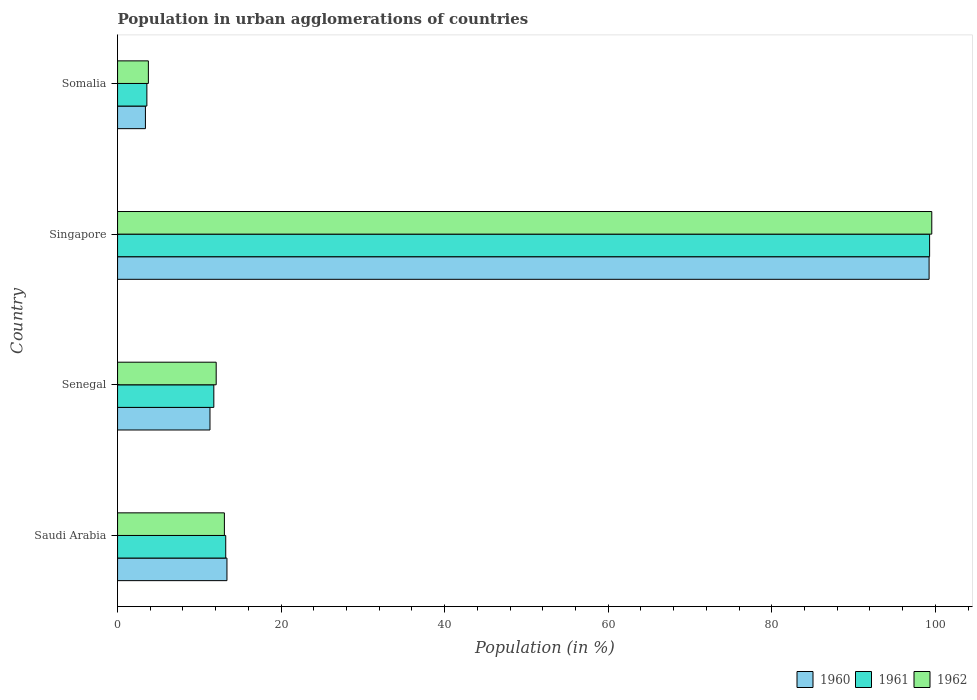How many different coloured bars are there?
Your response must be concise. 3. Are the number of bars per tick equal to the number of legend labels?
Offer a terse response. Yes. Are the number of bars on each tick of the Y-axis equal?
Your response must be concise. Yes. How many bars are there on the 3rd tick from the bottom?
Give a very brief answer. 3. What is the label of the 2nd group of bars from the top?
Your response must be concise. Singapore. What is the percentage of population in urban agglomerations in 1962 in Somalia?
Give a very brief answer. 3.77. Across all countries, what is the maximum percentage of population in urban agglomerations in 1960?
Offer a terse response. 99.23. Across all countries, what is the minimum percentage of population in urban agglomerations in 1962?
Provide a succinct answer. 3.77. In which country was the percentage of population in urban agglomerations in 1960 maximum?
Provide a succinct answer. Singapore. In which country was the percentage of population in urban agglomerations in 1961 minimum?
Provide a succinct answer. Somalia. What is the total percentage of population in urban agglomerations in 1961 in the graph?
Offer a terse response. 127.88. What is the difference between the percentage of population in urban agglomerations in 1960 in Senegal and that in Singapore?
Give a very brief answer. -87.93. What is the difference between the percentage of population in urban agglomerations in 1960 in Saudi Arabia and the percentage of population in urban agglomerations in 1961 in Somalia?
Provide a succinct answer. 9.79. What is the average percentage of population in urban agglomerations in 1962 per country?
Give a very brief answer. 32.11. What is the difference between the percentage of population in urban agglomerations in 1962 and percentage of population in urban agglomerations in 1961 in Singapore?
Give a very brief answer. 0.27. What is the ratio of the percentage of population in urban agglomerations in 1962 in Singapore to that in Somalia?
Give a very brief answer. 26.41. What is the difference between the highest and the second highest percentage of population in urban agglomerations in 1962?
Keep it short and to the point. 86.5. What is the difference between the highest and the lowest percentage of population in urban agglomerations in 1961?
Give a very brief answer. 95.71. In how many countries, is the percentage of population in urban agglomerations in 1960 greater than the average percentage of population in urban agglomerations in 1960 taken over all countries?
Your response must be concise. 1. Is the sum of the percentage of population in urban agglomerations in 1960 in Saudi Arabia and Singapore greater than the maximum percentage of population in urban agglomerations in 1961 across all countries?
Ensure brevity in your answer.  Yes. What does the 2nd bar from the top in Somalia represents?
Make the answer very short. 1961. Is it the case that in every country, the sum of the percentage of population in urban agglomerations in 1961 and percentage of population in urban agglomerations in 1962 is greater than the percentage of population in urban agglomerations in 1960?
Keep it short and to the point. Yes. Are all the bars in the graph horizontal?
Keep it short and to the point. Yes. How many countries are there in the graph?
Ensure brevity in your answer.  4. What is the difference between two consecutive major ticks on the X-axis?
Your response must be concise. 20. Are the values on the major ticks of X-axis written in scientific E-notation?
Keep it short and to the point. No. Does the graph contain grids?
Offer a terse response. No. How many legend labels are there?
Offer a terse response. 3. How are the legend labels stacked?
Give a very brief answer. Horizontal. What is the title of the graph?
Provide a short and direct response. Population in urban agglomerations of countries. What is the label or title of the X-axis?
Provide a short and direct response. Population (in %). What is the label or title of the Y-axis?
Offer a terse response. Country. What is the Population (in %) of 1960 in Saudi Arabia?
Provide a short and direct response. 13.38. What is the Population (in %) in 1961 in Saudi Arabia?
Ensure brevity in your answer.  13.23. What is the Population (in %) of 1962 in Saudi Arabia?
Make the answer very short. 13.06. What is the Population (in %) of 1960 in Senegal?
Give a very brief answer. 11.3. What is the Population (in %) in 1961 in Senegal?
Give a very brief answer. 11.77. What is the Population (in %) of 1962 in Senegal?
Offer a very short reply. 12.06. What is the Population (in %) of 1960 in Singapore?
Your response must be concise. 99.23. What is the Population (in %) in 1961 in Singapore?
Make the answer very short. 99.29. What is the Population (in %) of 1962 in Singapore?
Provide a short and direct response. 99.56. What is the Population (in %) in 1960 in Somalia?
Ensure brevity in your answer.  3.41. What is the Population (in %) in 1961 in Somalia?
Your response must be concise. 3.58. What is the Population (in %) in 1962 in Somalia?
Your response must be concise. 3.77. Across all countries, what is the maximum Population (in %) in 1960?
Make the answer very short. 99.23. Across all countries, what is the maximum Population (in %) of 1961?
Your answer should be compact. 99.29. Across all countries, what is the maximum Population (in %) of 1962?
Offer a very short reply. 99.56. Across all countries, what is the minimum Population (in %) of 1960?
Ensure brevity in your answer.  3.41. Across all countries, what is the minimum Population (in %) in 1961?
Make the answer very short. 3.58. Across all countries, what is the minimum Population (in %) in 1962?
Your response must be concise. 3.77. What is the total Population (in %) in 1960 in the graph?
Your answer should be compact. 127.31. What is the total Population (in %) in 1961 in the graph?
Keep it short and to the point. 127.88. What is the total Population (in %) of 1962 in the graph?
Provide a succinct answer. 128.45. What is the difference between the Population (in %) of 1960 in Saudi Arabia and that in Senegal?
Make the answer very short. 2.07. What is the difference between the Population (in %) in 1961 in Saudi Arabia and that in Senegal?
Offer a very short reply. 1.46. What is the difference between the Population (in %) of 1960 in Saudi Arabia and that in Singapore?
Make the answer very short. -85.85. What is the difference between the Population (in %) in 1961 in Saudi Arabia and that in Singapore?
Your response must be concise. -86.06. What is the difference between the Population (in %) in 1962 in Saudi Arabia and that in Singapore?
Provide a succinct answer. -86.5. What is the difference between the Population (in %) in 1960 in Saudi Arabia and that in Somalia?
Provide a short and direct response. 9.97. What is the difference between the Population (in %) of 1961 in Saudi Arabia and that in Somalia?
Provide a short and direct response. 9.64. What is the difference between the Population (in %) of 1962 in Saudi Arabia and that in Somalia?
Provide a succinct answer. 9.29. What is the difference between the Population (in %) of 1960 in Senegal and that in Singapore?
Offer a terse response. -87.93. What is the difference between the Population (in %) of 1961 in Senegal and that in Singapore?
Your response must be concise. -87.52. What is the difference between the Population (in %) of 1962 in Senegal and that in Singapore?
Your answer should be compact. -87.5. What is the difference between the Population (in %) in 1960 in Senegal and that in Somalia?
Provide a succinct answer. 7.89. What is the difference between the Population (in %) of 1961 in Senegal and that in Somalia?
Offer a terse response. 8.19. What is the difference between the Population (in %) of 1962 in Senegal and that in Somalia?
Provide a short and direct response. 8.29. What is the difference between the Population (in %) of 1960 in Singapore and that in Somalia?
Provide a short and direct response. 95.82. What is the difference between the Population (in %) of 1961 in Singapore and that in Somalia?
Provide a succinct answer. 95.71. What is the difference between the Population (in %) in 1962 in Singapore and that in Somalia?
Your answer should be very brief. 95.79. What is the difference between the Population (in %) of 1960 in Saudi Arabia and the Population (in %) of 1961 in Senegal?
Make the answer very short. 1.6. What is the difference between the Population (in %) in 1960 in Saudi Arabia and the Population (in %) in 1962 in Senegal?
Keep it short and to the point. 1.32. What is the difference between the Population (in %) in 1961 in Saudi Arabia and the Population (in %) in 1962 in Senegal?
Provide a short and direct response. 1.17. What is the difference between the Population (in %) in 1960 in Saudi Arabia and the Population (in %) in 1961 in Singapore?
Provide a succinct answer. -85.92. What is the difference between the Population (in %) of 1960 in Saudi Arabia and the Population (in %) of 1962 in Singapore?
Provide a succinct answer. -86.18. What is the difference between the Population (in %) in 1961 in Saudi Arabia and the Population (in %) in 1962 in Singapore?
Provide a short and direct response. -86.33. What is the difference between the Population (in %) in 1960 in Saudi Arabia and the Population (in %) in 1961 in Somalia?
Your answer should be compact. 9.79. What is the difference between the Population (in %) of 1960 in Saudi Arabia and the Population (in %) of 1962 in Somalia?
Give a very brief answer. 9.61. What is the difference between the Population (in %) in 1961 in Saudi Arabia and the Population (in %) in 1962 in Somalia?
Your response must be concise. 9.46. What is the difference between the Population (in %) in 1960 in Senegal and the Population (in %) in 1961 in Singapore?
Your answer should be very brief. -87.99. What is the difference between the Population (in %) in 1960 in Senegal and the Population (in %) in 1962 in Singapore?
Provide a succinct answer. -88.26. What is the difference between the Population (in %) in 1961 in Senegal and the Population (in %) in 1962 in Singapore?
Provide a succinct answer. -87.79. What is the difference between the Population (in %) of 1960 in Senegal and the Population (in %) of 1961 in Somalia?
Provide a succinct answer. 7.72. What is the difference between the Population (in %) in 1960 in Senegal and the Population (in %) in 1962 in Somalia?
Provide a succinct answer. 7.53. What is the difference between the Population (in %) in 1961 in Senegal and the Population (in %) in 1962 in Somalia?
Give a very brief answer. 8. What is the difference between the Population (in %) in 1960 in Singapore and the Population (in %) in 1961 in Somalia?
Keep it short and to the point. 95.65. What is the difference between the Population (in %) in 1960 in Singapore and the Population (in %) in 1962 in Somalia?
Provide a succinct answer. 95.46. What is the difference between the Population (in %) in 1961 in Singapore and the Population (in %) in 1962 in Somalia?
Keep it short and to the point. 95.52. What is the average Population (in %) of 1960 per country?
Ensure brevity in your answer.  31.83. What is the average Population (in %) in 1961 per country?
Keep it short and to the point. 31.97. What is the average Population (in %) in 1962 per country?
Your answer should be compact. 32.11. What is the difference between the Population (in %) in 1960 and Population (in %) in 1961 in Saudi Arabia?
Keep it short and to the point. 0.15. What is the difference between the Population (in %) in 1960 and Population (in %) in 1962 in Saudi Arabia?
Ensure brevity in your answer.  0.31. What is the difference between the Population (in %) of 1961 and Population (in %) of 1962 in Saudi Arabia?
Give a very brief answer. 0.17. What is the difference between the Population (in %) of 1960 and Population (in %) of 1961 in Senegal?
Offer a very short reply. -0.47. What is the difference between the Population (in %) in 1960 and Population (in %) in 1962 in Senegal?
Provide a short and direct response. -0.76. What is the difference between the Population (in %) in 1961 and Population (in %) in 1962 in Senegal?
Offer a very short reply. -0.29. What is the difference between the Population (in %) in 1960 and Population (in %) in 1961 in Singapore?
Provide a succinct answer. -0.06. What is the difference between the Population (in %) in 1960 and Population (in %) in 1962 in Singapore?
Provide a short and direct response. -0.33. What is the difference between the Population (in %) in 1961 and Population (in %) in 1962 in Singapore?
Give a very brief answer. -0.27. What is the difference between the Population (in %) in 1960 and Population (in %) in 1961 in Somalia?
Keep it short and to the point. -0.18. What is the difference between the Population (in %) of 1960 and Population (in %) of 1962 in Somalia?
Keep it short and to the point. -0.36. What is the difference between the Population (in %) in 1961 and Population (in %) in 1962 in Somalia?
Offer a very short reply. -0.19. What is the ratio of the Population (in %) of 1960 in Saudi Arabia to that in Senegal?
Ensure brevity in your answer.  1.18. What is the ratio of the Population (in %) in 1961 in Saudi Arabia to that in Senegal?
Provide a short and direct response. 1.12. What is the ratio of the Population (in %) in 1962 in Saudi Arabia to that in Senegal?
Provide a short and direct response. 1.08. What is the ratio of the Population (in %) in 1960 in Saudi Arabia to that in Singapore?
Make the answer very short. 0.13. What is the ratio of the Population (in %) in 1961 in Saudi Arabia to that in Singapore?
Keep it short and to the point. 0.13. What is the ratio of the Population (in %) of 1962 in Saudi Arabia to that in Singapore?
Provide a succinct answer. 0.13. What is the ratio of the Population (in %) in 1960 in Saudi Arabia to that in Somalia?
Your answer should be compact. 3.93. What is the ratio of the Population (in %) of 1961 in Saudi Arabia to that in Somalia?
Your answer should be compact. 3.69. What is the ratio of the Population (in %) of 1962 in Saudi Arabia to that in Somalia?
Offer a very short reply. 3.47. What is the ratio of the Population (in %) of 1960 in Senegal to that in Singapore?
Provide a short and direct response. 0.11. What is the ratio of the Population (in %) in 1961 in Senegal to that in Singapore?
Offer a terse response. 0.12. What is the ratio of the Population (in %) of 1962 in Senegal to that in Singapore?
Give a very brief answer. 0.12. What is the ratio of the Population (in %) of 1960 in Senegal to that in Somalia?
Make the answer very short. 3.32. What is the ratio of the Population (in %) of 1961 in Senegal to that in Somalia?
Provide a succinct answer. 3.28. What is the ratio of the Population (in %) of 1962 in Senegal to that in Somalia?
Your response must be concise. 3.2. What is the ratio of the Population (in %) in 1960 in Singapore to that in Somalia?
Provide a succinct answer. 29.12. What is the ratio of the Population (in %) of 1961 in Singapore to that in Somalia?
Ensure brevity in your answer.  27.7. What is the ratio of the Population (in %) of 1962 in Singapore to that in Somalia?
Your response must be concise. 26.41. What is the difference between the highest and the second highest Population (in %) of 1960?
Ensure brevity in your answer.  85.85. What is the difference between the highest and the second highest Population (in %) of 1961?
Your response must be concise. 86.06. What is the difference between the highest and the second highest Population (in %) of 1962?
Offer a very short reply. 86.5. What is the difference between the highest and the lowest Population (in %) of 1960?
Provide a succinct answer. 95.82. What is the difference between the highest and the lowest Population (in %) of 1961?
Give a very brief answer. 95.71. What is the difference between the highest and the lowest Population (in %) in 1962?
Provide a succinct answer. 95.79. 